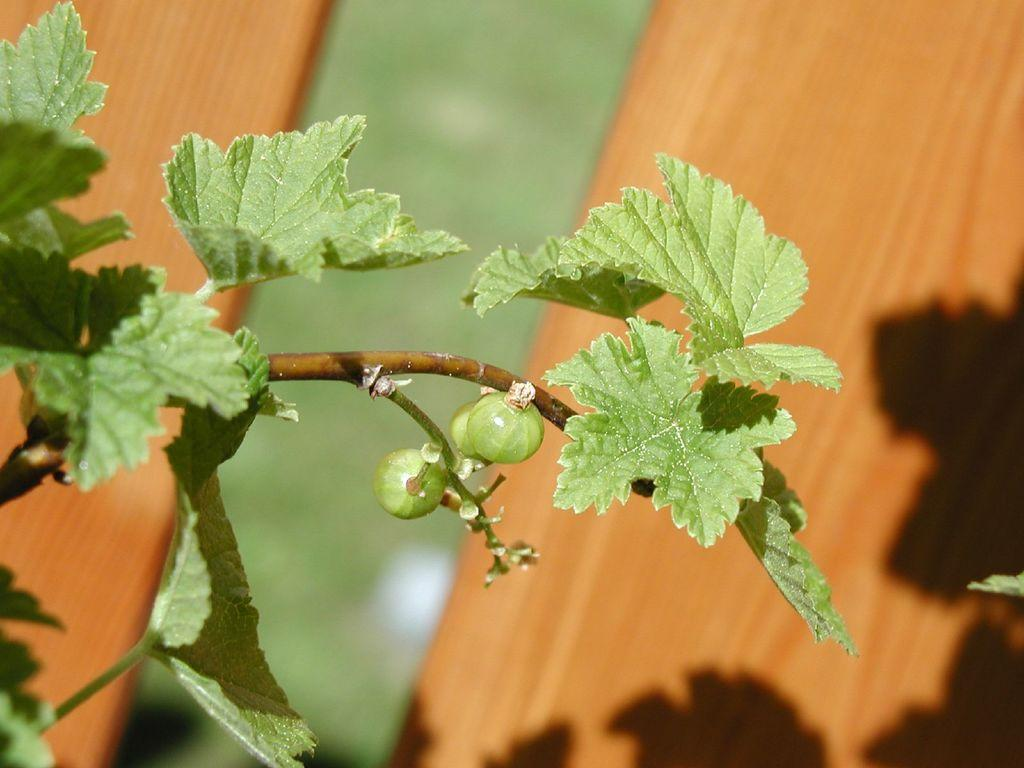What type of objects resemble fruits in the image? There are objects in the image that resemble fruits. How are these fruits connected to the branches? These fruits are attached to stems and branches. What else can be seen on the branches besides the fruits? There are leaves on the branches. What type of barrier is visible in the image? There is a wooden fence visible in the image. Are there any bears interacting with the fruits in the image? There are no bears present in the image; it only features fruits, branches, leaves, and a wooden fence. 